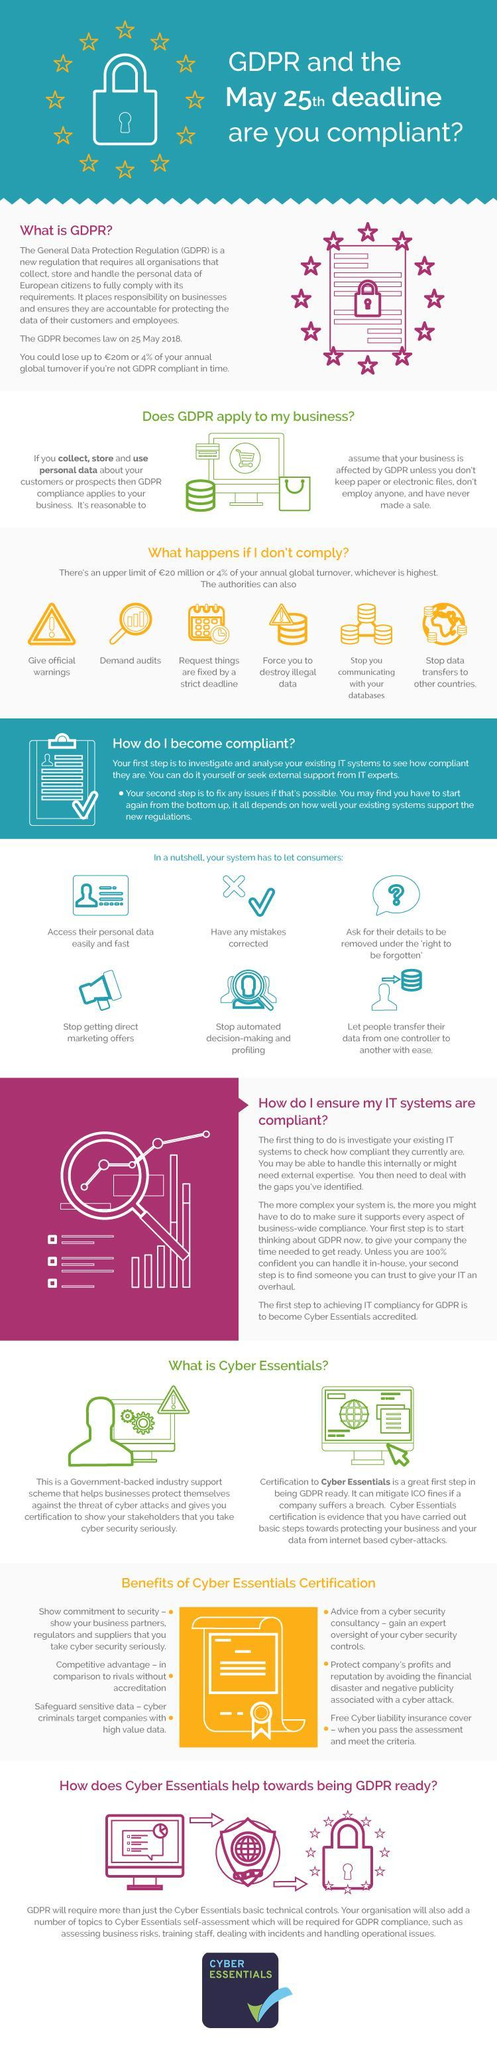Name the government backed support scheme that helps businesses protect themselves from cyber attacks ?
Answer the question with a short phrase. Cyber Essentials What is the colour of the cyber essential certificate in the image - yellow, red or blue ? Yellow What is the punctuation mark shown in the triangle - question mark, exclamation mark or quotations ? Exclamation mark How many bullet points are there under Benefits of Cyber Essentials certification ? 6 